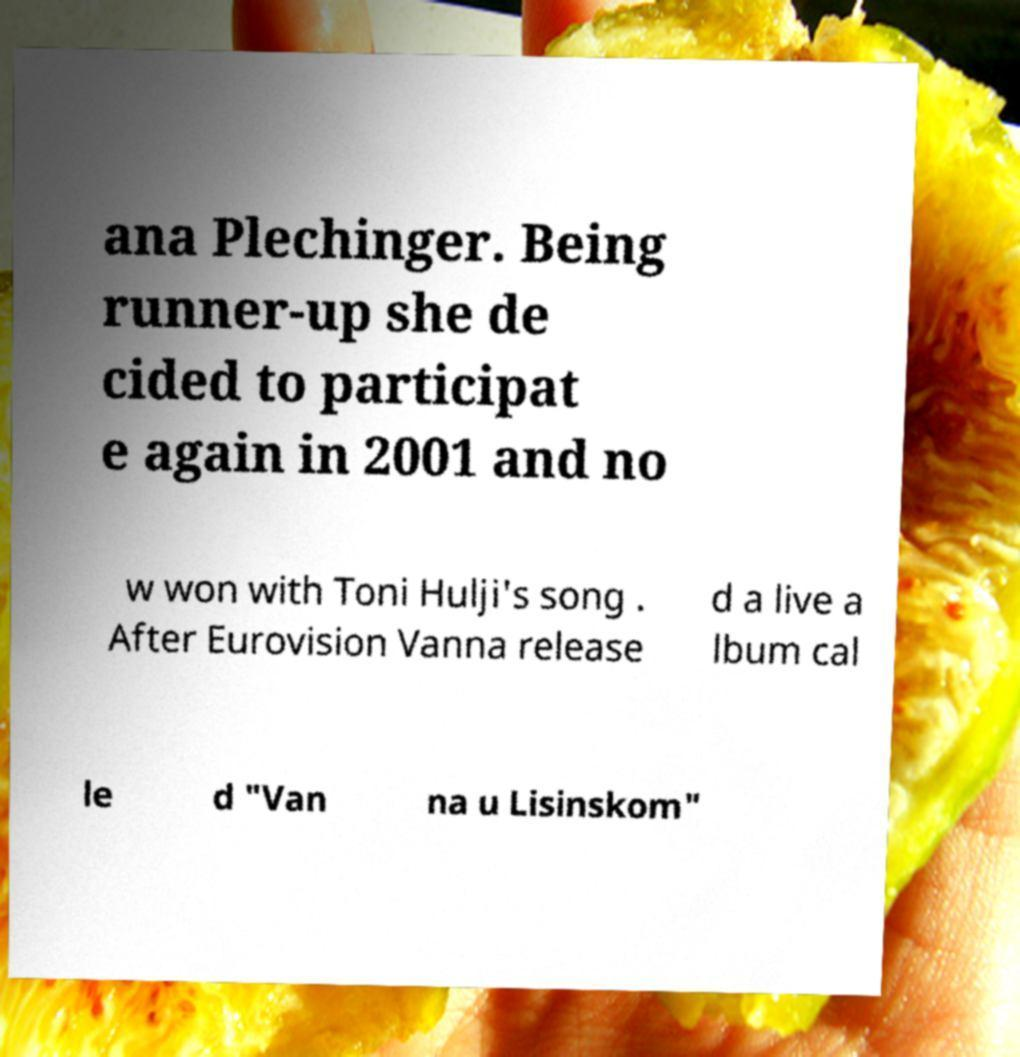There's text embedded in this image that I need extracted. Can you transcribe it verbatim? ana Plechinger. Being runner-up she de cided to participat e again in 2001 and no w won with Toni Hulji's song . After Eurovision Vanna release d a live a lbum cal le d "Van na u Lisinskom" 